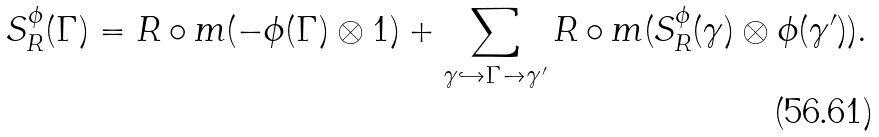Convert formula to latex. <formula><loc_0><loc_0><loc_500><loc_500>S ^ { \phi } _ { R } ( \Gamma ) = R \circ m ( - \phi ( \Gamma ) \otimes 1 ) + \sum _ { \gamma \hookrightarrow \Gamma \to \gamma ^ { \prime } } R \circ m ( S ^ { \phi } _ { R } ( \gamma ) \otimes \phi ( \gamma ^ { \prime } ) ) .</formula> 